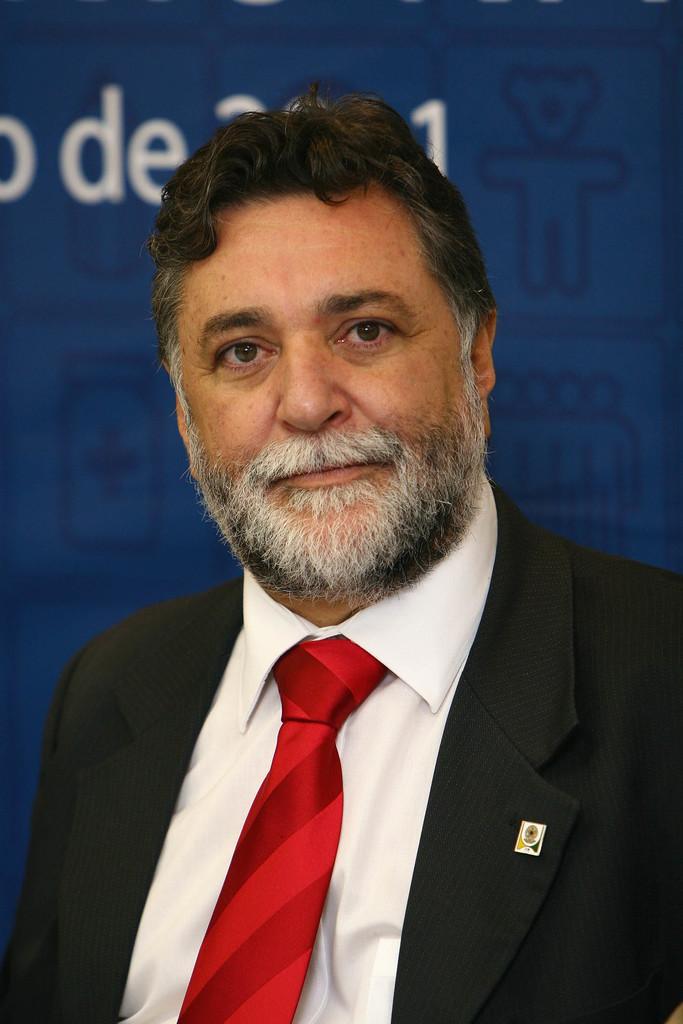Please provide a concise description of this image. There is a man smiling and wore black suit and red tie. In the background it is blue. 